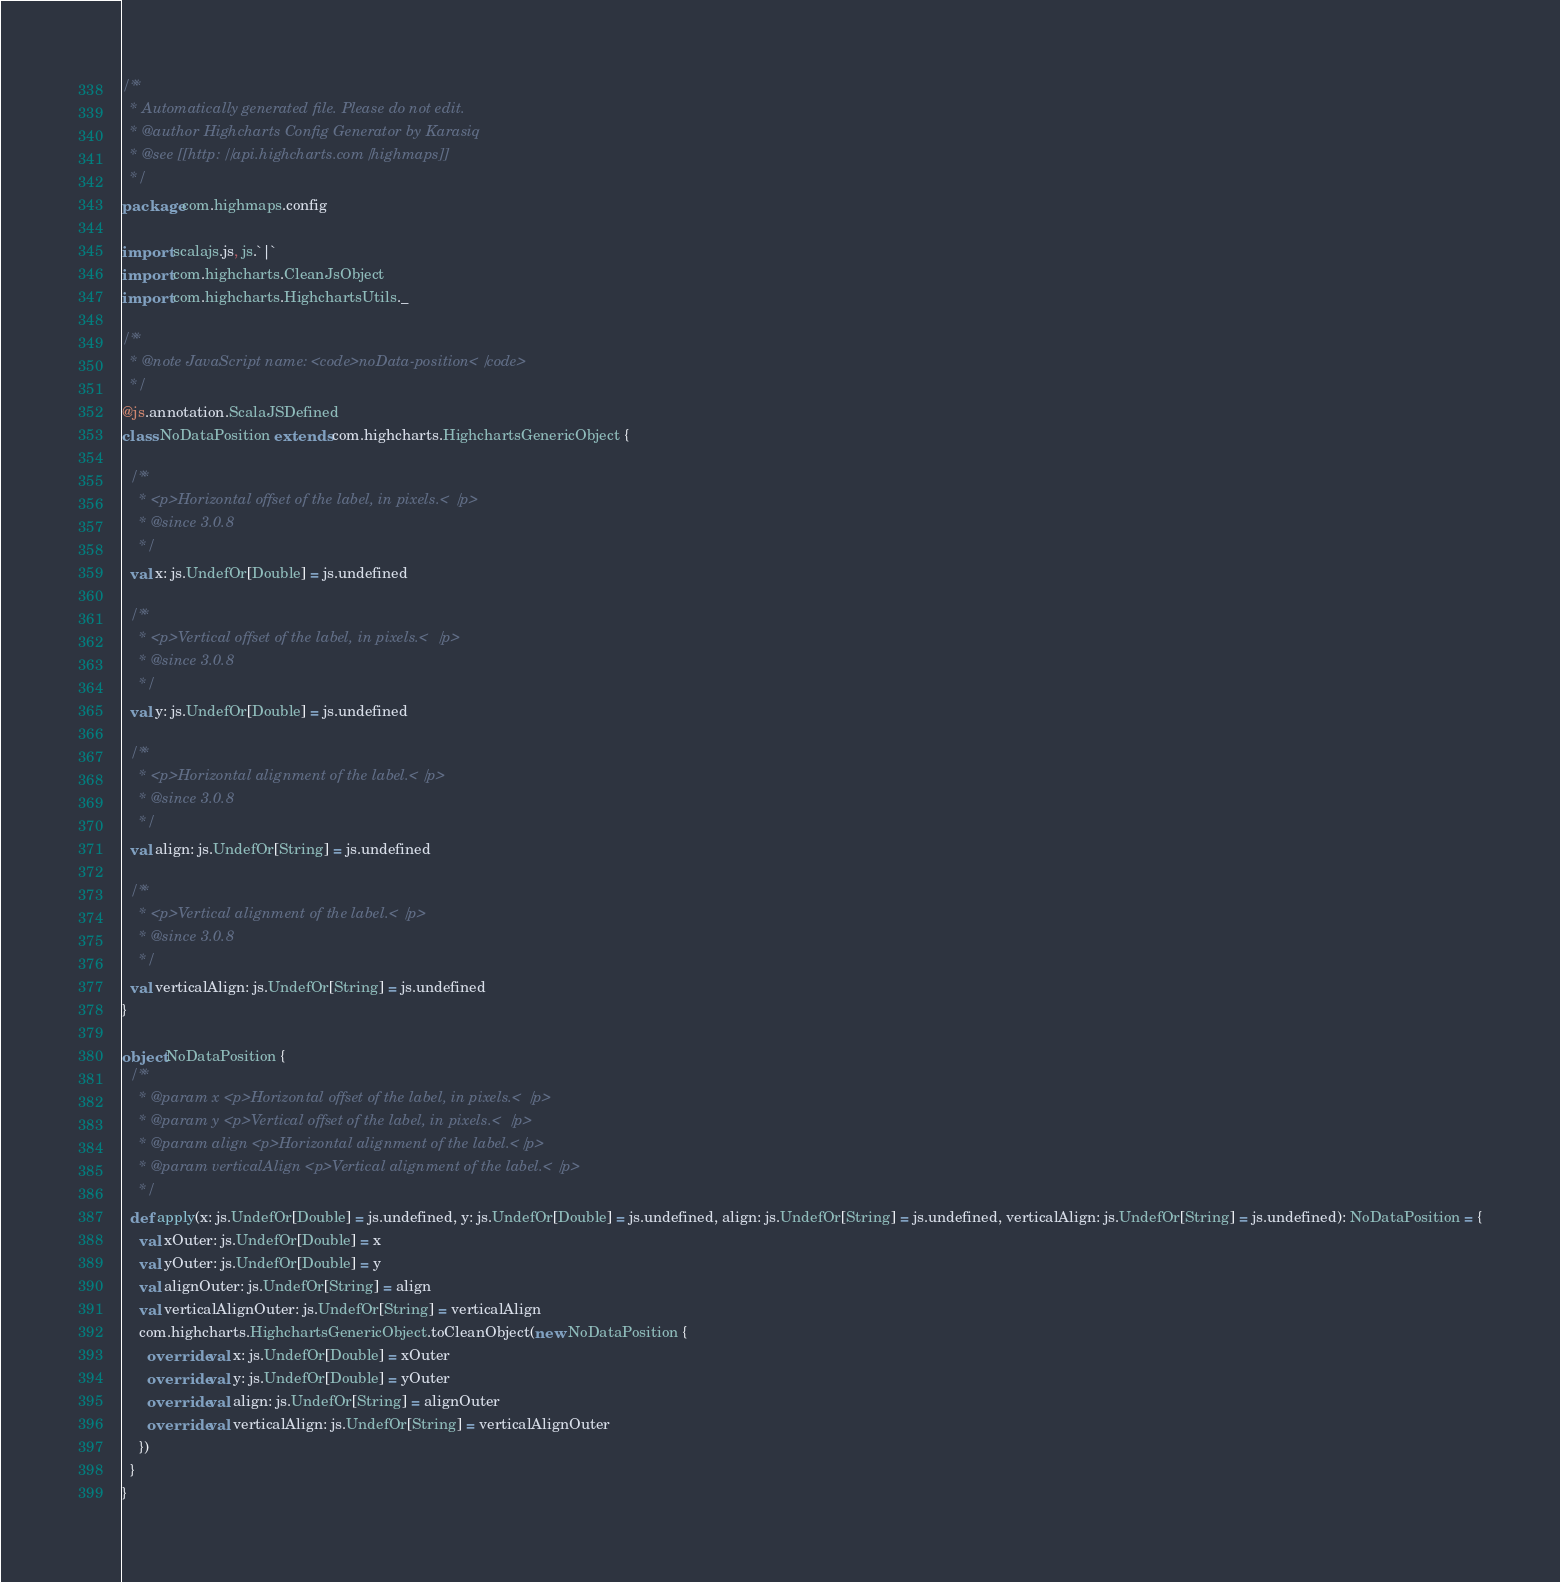<code> <loc_0><loc_0><loc_500><loc_500><_Scala_>/**
  * Automatically generated file. Please do not edit.
  * @author Highcharts Config Generator by Karasiq
  * @see [[http://api.highcharts.com/highmaps]]
  */
package com.highmaps.config

import scalajs.js, js.`|`
import com.highcharts.CleanJsObject
import com.highcharts.HighchartsUtils._

/**
  * @note JavaScript name: <code>noData-position</code>
  */
@js.annotation.ScalaJSDefined
class NoDataPosition extends com.highcharts.HighchartsGenericObject {

  /**
    * <p>Horizontal offset of the label, in pixels.</p>
    * @since 3.0.8
    */
  val x: js.UndefOr[Double] = js.undefined

  /**
    * <p>Vertical offset of the label, in pixels.</p>
    * @since 3.0.8
    */
  val y: js.UndefOr[Double] = js.undefined

  /**
    * <p>Horizontal alignment of the label.</p>
    * @since 3.0.8
    */
  val align: js.UndefOr[String] = js.undefined

  /**
    * <p>Vertical alignment of the label.</p>
    * @since 3.0.8
    */
  val verticalAlign: js.UndefOr[String] = js.undefined
}

object NoDataPosition {
  /**
    * @param x <p>Horizontal offset of the label, in pixels.</p>
    * @param y <p>Vertical offset of the label, in pixels.</p>
    * @param align <p>Horizontal alignment of the label.</p>
    * @param verticalAlign <p>Vertical alignment of the label.</p>
    */
  def apply(x: js.UndefOr[Double] = js.undefined, y: js.UndefOr[Double] = js.undefined, align: js.UndefOr[String] = js.undefined, verticalAlign: js.UndefOr[String] = js.undefined): NoDataPosition = {
    val xOuter: js.UndefOr[Double] = x
    val yOuter: js.UndefOr[Double] = y
    val alignOuter: js.UndefOr[String] = align
    val verticalAlignOuter: js.UndefOr[String] = verticalAlign
    com.highcharts.HighchartsGenericObject.toCleanObject(new NoDataPosition {
      override val x: js.UndefOr[Double] = xOuter
      override val y: js.UndefOr[Double] = yOuter
      override val align: js.UndefOr[String] = alignOuter
      override val verticalAlign: js.UndefOr[String] = verticalAlignOuter
    })
  }
}
</code> 